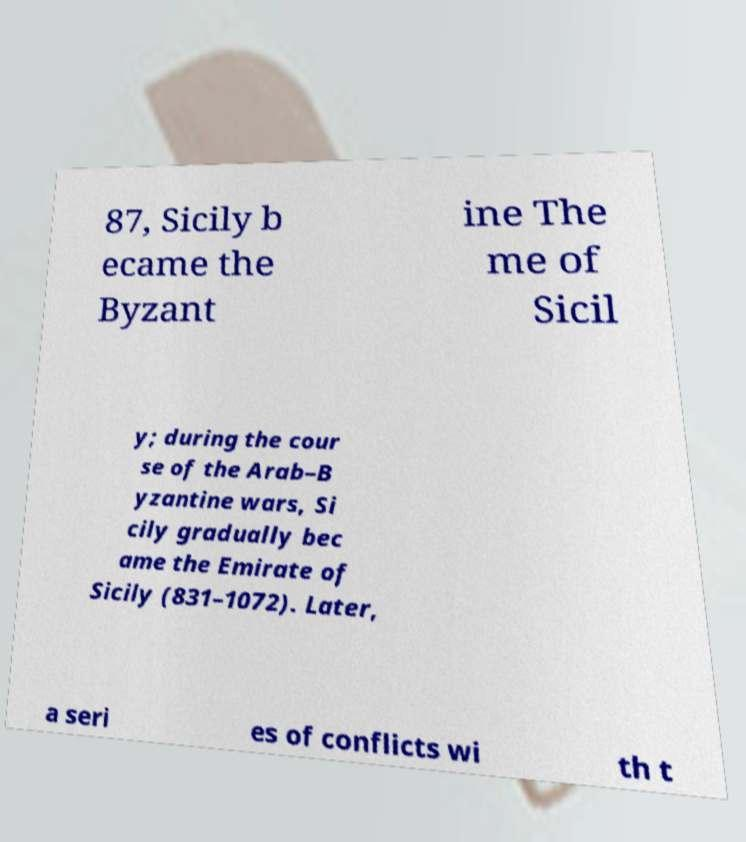What messages or text are displayed in this image? I need them in a readable, typed format. 87, Sicily b ecame the Byzant ine The me of Sicil y; during the cour se of the Arab–B yzantine wars, Si cily gradually bec ame the Emirate of Sicily (831–1072). Later, a seri es of conflicts wi th t 